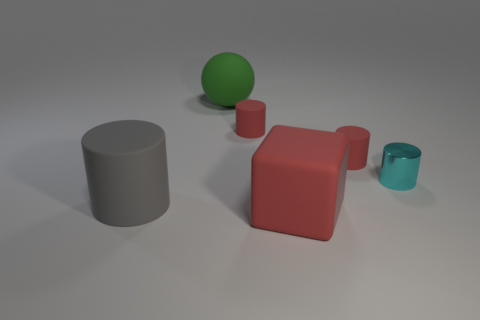Do the big cube and the green ball have the same material?
Your response must be concise. Yes. Is the number of red rubber cylinders right of the rubber block less than the number of red things that are left of the small metallic cylinder?
Keep it short and to the point. Yes. There is a large object that is in front of the big matte thing that is on the left side of the large ball; how many small cylinders are to the right of it?
Your answer should be very brief. 2. Is there a cylinder of the same color as the cube?
Your answer should be very brief. Yes. The cube that is the same size as the ball is what color?
Ensure brevity in your answer.  Red. Are there any metal things of the same shape as the large gray matte object?
Ensure brevity in your answer.  Yes. Are there any big rubber spheres that are on the right side of the gray cylinder on the left side of the red thing in front of the small metallic thing?
Provide a short and direct response. Yes. The gray object that is the same size as the green rubber ball is what shape?
Offer a very short reply. Cylinder. There is another tiny metallic object that is the same shape as the gray thing; what color is it?
Give a very brief answer. Cyan. How many objects are small red metal things or big matte things?
Offer a terse response. 3. 